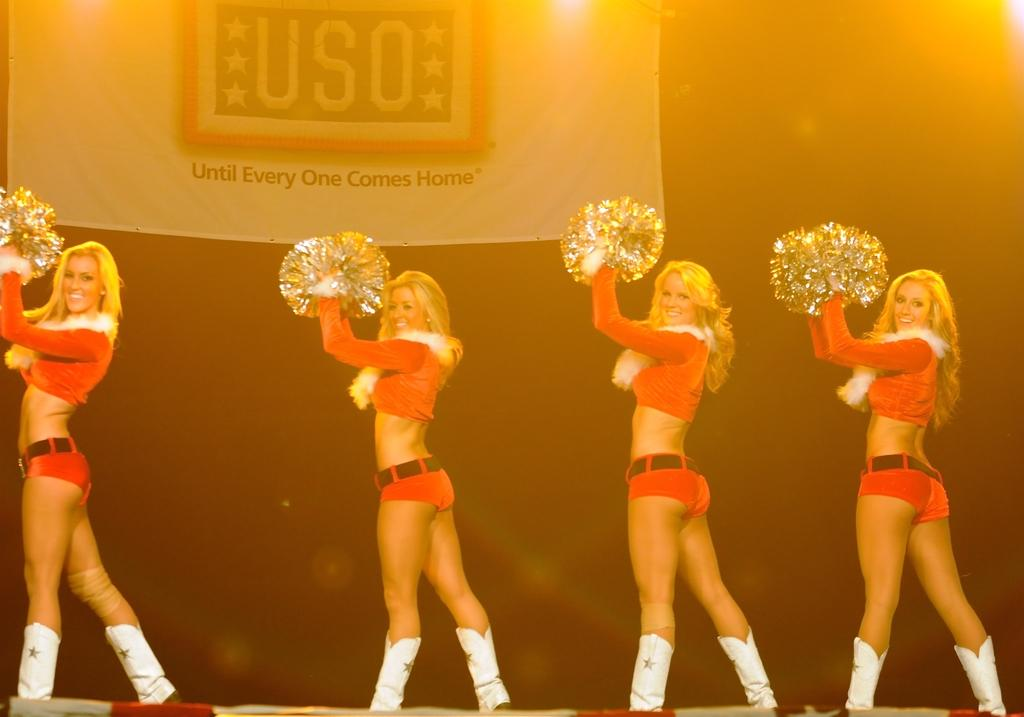What is happening in the image involving the women? The women appear to be dancing in the image. Can you describe any other elements in the image besides the women? Yes, there is a poster visible in the image. What type of bikes can be seen in the image? There are no bikes present in the image. How does the rainstorm affect the women's dancing in the image? There is no rainstorm depicted in the image, so its effect on the women's dancing cannot be determined. 